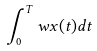<formula> <loc_0><loc_0><loc_500><loc_500>\int _ { 0 } ^ { T } w x ( t ) d t</formula> 